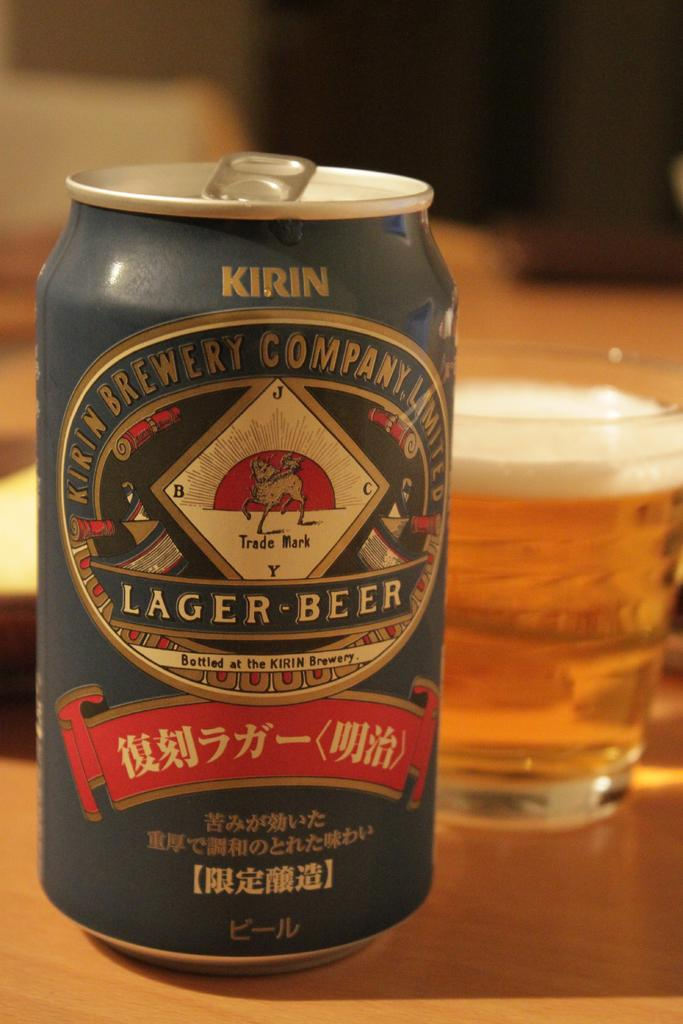<image>
Share a concise interpretation of the image provided. A can of Kirin beer is on a table with a glass behind it. 